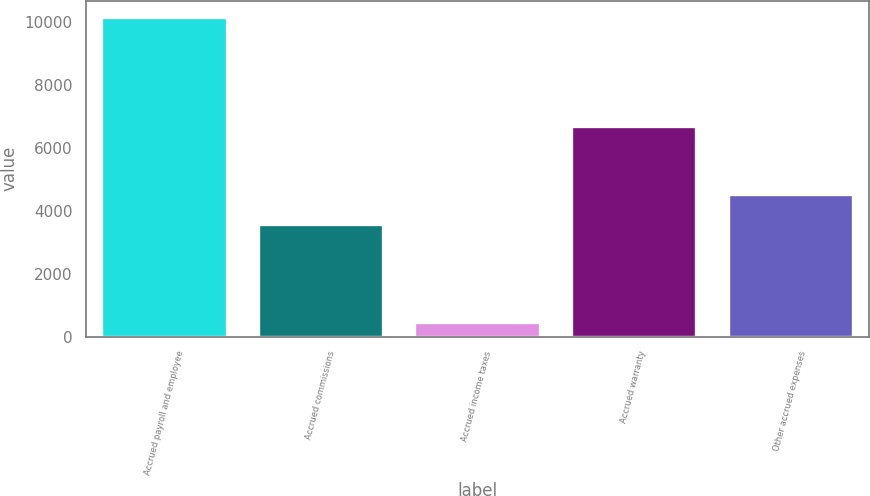Convert chart to OTSL. <chart><loc_0><loc_0><loc_500><loc_500><bar_chart><fcel>Accrued payroll and employee<fcel>Accrued commissions<fcel>Accrued income taxes<fcel>Accrued warranty<fcel>Other accrued expenses<nl><fcel>10143<fcel>3569<fcel>447<fcel>6674<fcel>4538.6<nl></chart> 